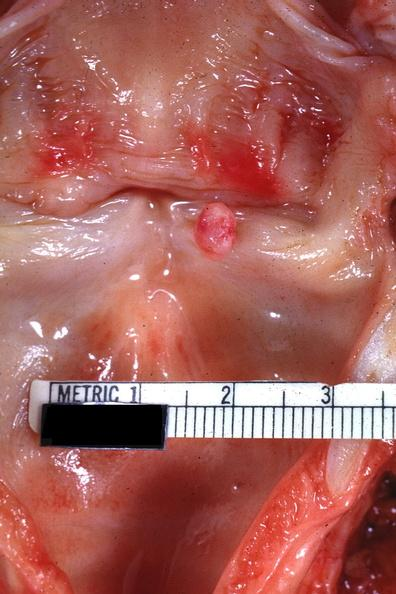s papilloma on vocal cord present?
Answer the question using a single word or phrase. Yes 